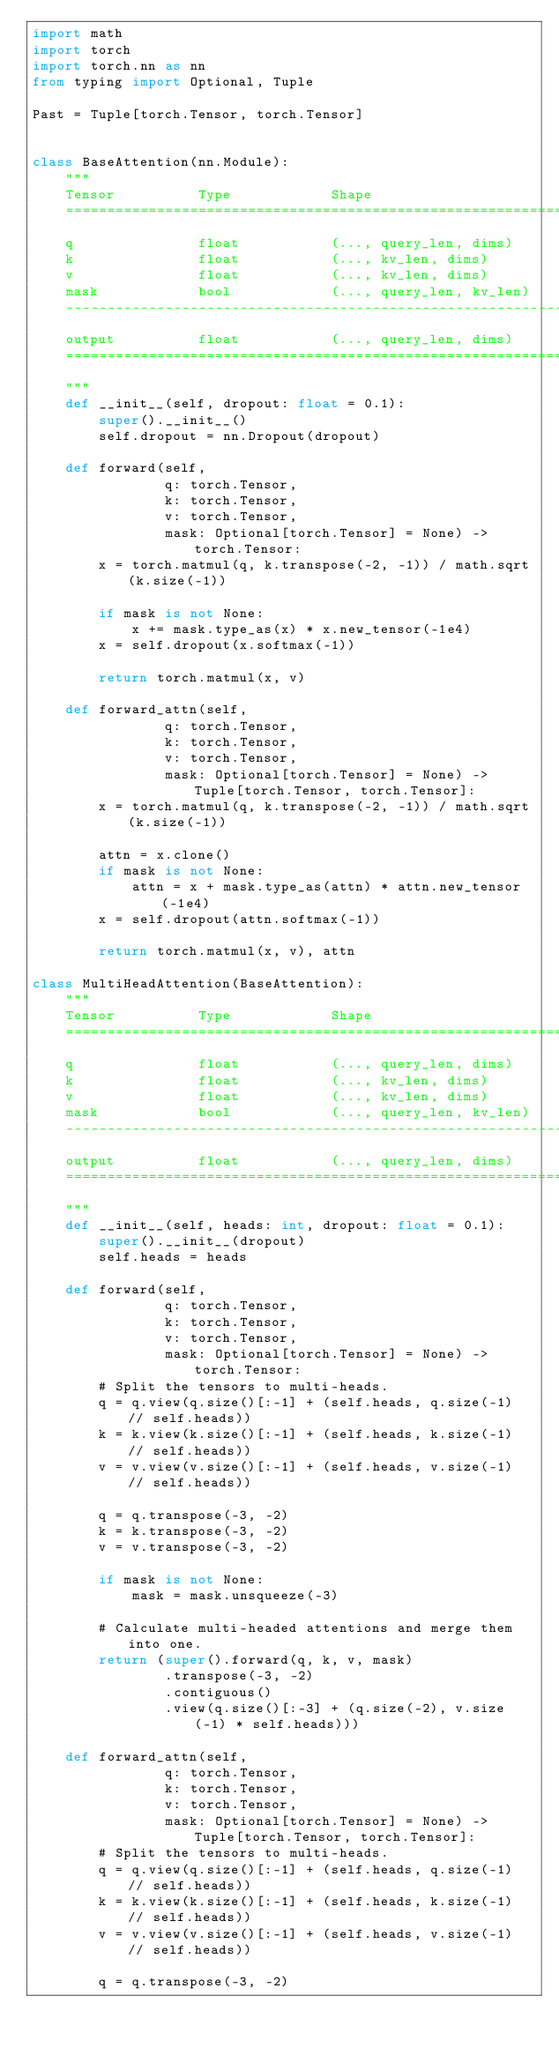<code> <loc_0><loc_0><loc_500><loc_500><_Python_>import math
import torch
import torch.nn as nn
from typing import Optional, Tuple

Past = Tuple[torch.Tensor, torch.Tensor]


class BaseAttention(nn.Module):
    """
    Tensor          Type            Shape
    ===========================================================================
    q               float           (..., query_len, dims)
    k               float           (..., kv_len, dims)
    v               float           (..., kv_len, dims)
    mask            bool            (..., query_len, kv_len)
    ---------------------------------------------------------------------------
    output          float           (..., query_len, dims)
    ===========================================================================
    """
    def __init__(self, dropout: float = 0.1):
        super().__init__()
        self.dropout = nn.Dropout(dropout)

    def forward(self,
                q: torch.Tensor,
                k: torch.Tensor,
                v: torch.Tensor,
                mask: Optional[torch.Tensor] = None) -> torch.Tensor:
        x = torch.matmul(q, k.transpose(-2, -1)) / math.sqrt(k.size(-1))

        if mask is not None:
            x += mask.type_as(x) * x.new_tensor(-1e4)
        x = self.dropout(x.softmax(-1))

        return torch.matmul(x, v)

    def forward_attn(self,
                q: torch.Tensor,
                k: torch.Tensor,
                v: torch.Tensor,
                mask: Optional[torch.Tensor] = None) -> Tuple[torch.Tensor, torch.Tensor]:
        x = torch.matmul(q, k.transpose(-2, -1)) / math.sqrt(k.size(-1))

        attn = x.clone()
        if mask is not None:
            attn = x + mask.type_as(attn) * attn.new_tensor(-1e4)
        x = self.dropout(attn.softmax(-1))
        
        return torch.matmul(x, v), attn

class MultiHeadAttention(BaseAttention):
    """
    Tensor          Type            Shape
    ===========================================================================
    q               float           (..., query_len, dims)
    k               float           (..., kv_len, dims)
    v               float           (..., kv_len, dims)
    mask            bool            (..., query_len, kv_len)
    ---------------------------------------------------------------------------
    output          float           (..., query_len, dims)
    ===========================================================================
    """
    def __init__(self, heads: int, dropout: float = 0.1):
        super().__init__(dropout)
        self.heads = heads

    def forward(self,
                q: torch.Tensor,
                k: torch.Tensor,
                v: torch.Tensor,
                mask: Optional[torch.Tensor] = None) -> torch.Tensor:
        # Split the tensors to multi-heads.
        q = q.view(q.size()[:-1] + (self.heads, q.size(-1) // self.heads))
        k = k.view(k.size()[:-1] + (self.heads, k.size(-1) // self.heads))
        v = v.view(v.size()[:-1] + (self.heads, v.size(-1) // self.heads))

        q = q.transpose(-3, -2)
        k = k.transpose(-3, -2)
        v = v.transpose(-3, -2)

        if mask is not None:
            mask = mask.unsqueeze(-3)

        # Calculate multi-headed attentions and merge them into one.
        return (super().forward(q, k, v, mask)
                .transpose(-3, -2)
                .contiguous()
                .view(q.size()[:-3] + (q.size(-2), v.size(-1) * self.heads)))
    
    def forward_attn(self,
                q: torch.Tensor,
                k: torch.Tensor,
                v: torch.Tensor,
                mask: Optional[torch.Tensor] = None) -> Tuple[torch.Tensor, torch.Tensor]:
        # Split the tensors to multi-heads.
        q = q.view(q.size()[:-1] + (self.heads, q.size(-1) // self.heads))
        k = k.view(k.size()[:-1] + (self.heads, k.size(-1) // self.heads))
        v = v.view(v.size()[:-1] + (self.heads, v.size(-1) // self.heads))

        q = q.transpose(-3, -2)</code> 